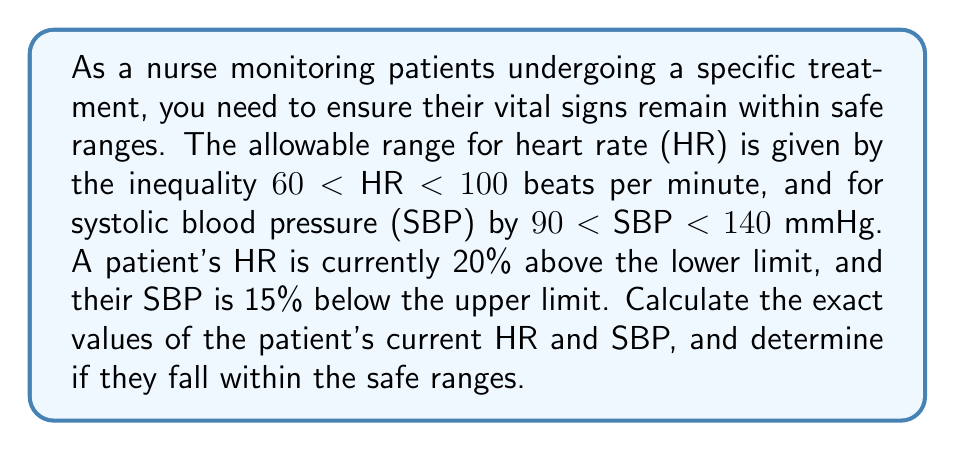Can you solve this math problem? 1. Heart Rate (HR):
   - Lower limit: 60 bpm
   - Patient's HR is 20% above the lower limit
   - Calculate: $60 + (20\% \times 60) = 60 + 0.2 \times 60 = 60 + 12 = 72$ bpm

2. Systolic Blood Pressure (SBP):
   - Upper limit: 140 mmHg
   - Patient's SBP is 15% below the upper limit
   - Calculate: $140 - (15\% \times 140) = 140 - 0.15 \times 140 = 140 - 21 = 119$ mmHg

3. Check if HR is within safe range:
   $60 < 72 < 100$ (True)

4. Check if SBP is within safe range:
   $90 < 119 < 140$ (True)

Both vital signs fall within the safe ranges.
Answer: HR = 72 bpm, SBP = 119 mmHg; both within safe ranges. 